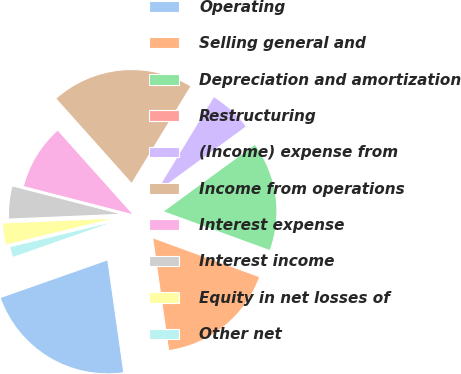<chart> <loc_0><loc_0><loc_500><loc_500><pie_chart><fcel>Operating<fcel>Selling general and<fcel>Depreciation and amortization<fcel>Restructuring<fcel>(Income) expense from<fcel>Income from operations<fcel>Interest expense<fcel>Interest income<fcel>Equity in net losses of<fcel>Other net<nl><fcel>21.87%<fcel>17.18%<fcel>15.62%<fcel>0.0%<fcel>6.25%<fcel>20.31%<fcel>9.38%<fcel>4.69%<fcel>3.13%<fcel>1.57%<nl></chart> 